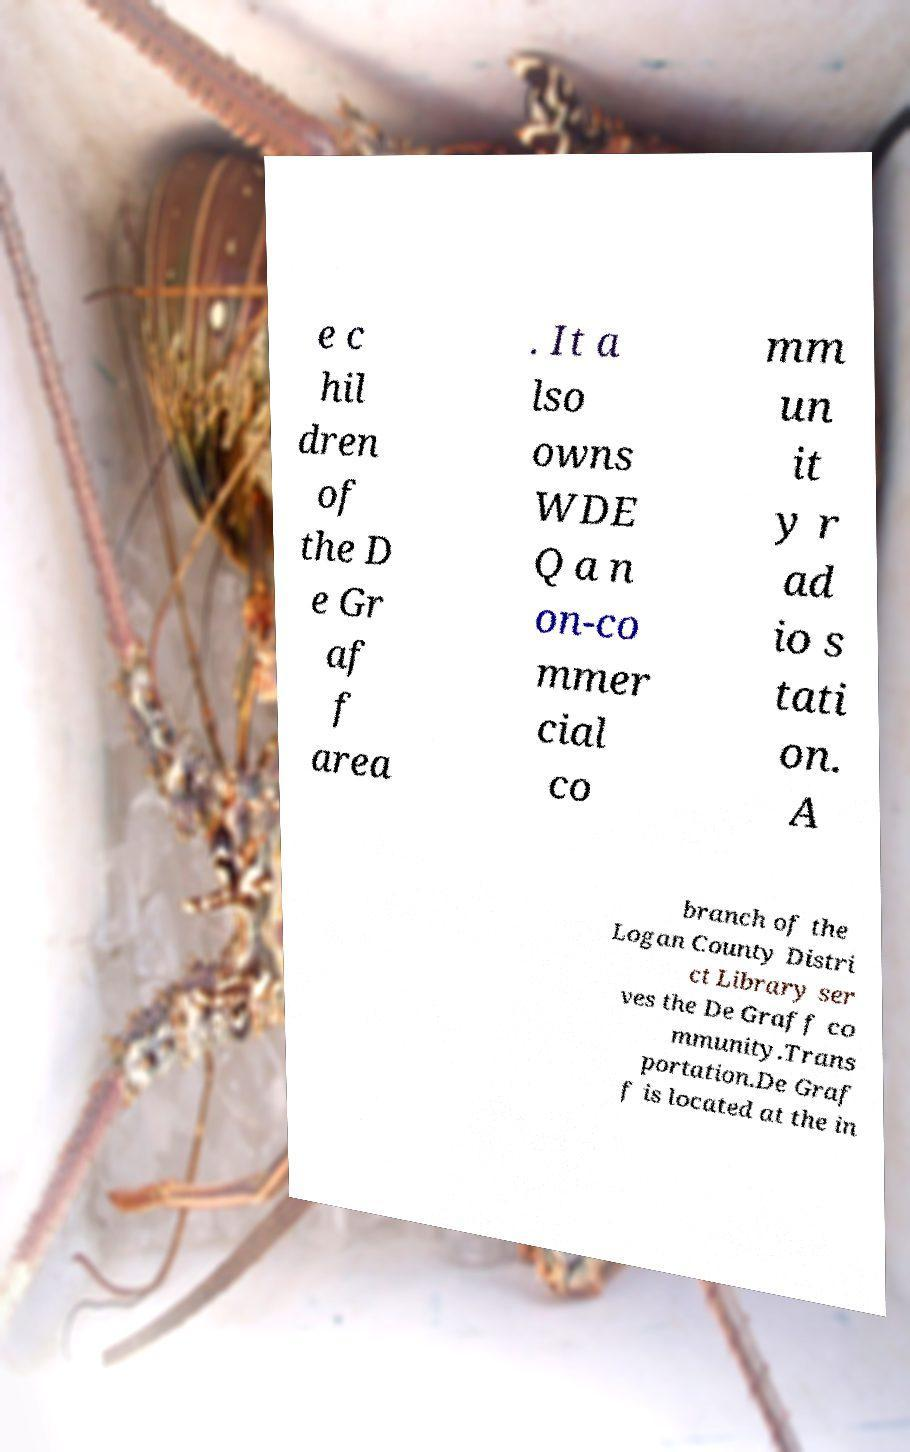For documentation purposes, I need the text within this image transcribed. Could you provide that? e c hil dren of the D e Gr af f area . It a lso owns WDE Q a n on-co mmer cial co mm un it y r ad io s tati on. A branch of the Logan County Distri ct Library ser ves the De Graff co mmunity.Trans portation.De Graf f is located at the in 